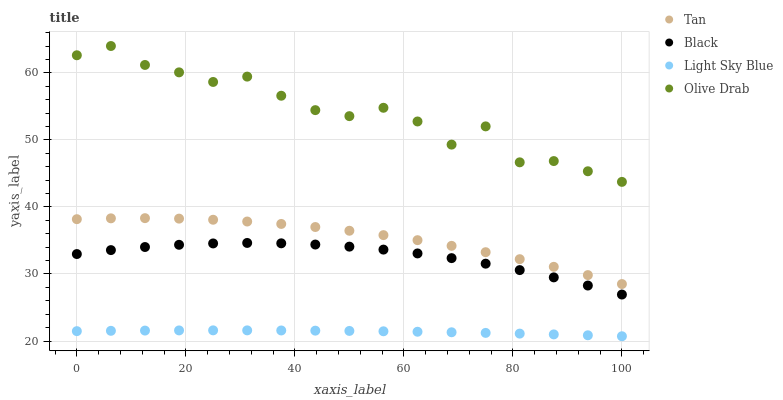Does Light Sky Blue have the minimum area under the curve?
Answer yes or no. Yes. Does Olive Drab have the maximum area under the curve?
Answer yes or no. Yes. Does Black have the minimum area under the curve?
Answer yes or no. No. Does Black have the maximum area under the curve?
Answer yes or no. No. Is Light Sky Blue the smoothest?
Answer yes or no. Yes. Is Olive Drab the roughest?
Answer yes or no. Yes. Is Black the smoothest?
Answer yes or no. No. Is Black the roughest?
Answer yes or no. No. Does Light Sky Blue have the lowest value?
Answer yes or no. Yes. Does Black have the lowest value?
Answer yes or no. No. Does Olive Drab have the highest value?
Answer yes or no. Yes. Does Black have the highest value?
Answer yes or no. No. Is Black less than Tan?
Answer yes or no. Yes. Is Tan greater than Light Sky Blue?
Answer yes or no. Yes. Does Black intersect Tan?
Answer yes or no. No. 